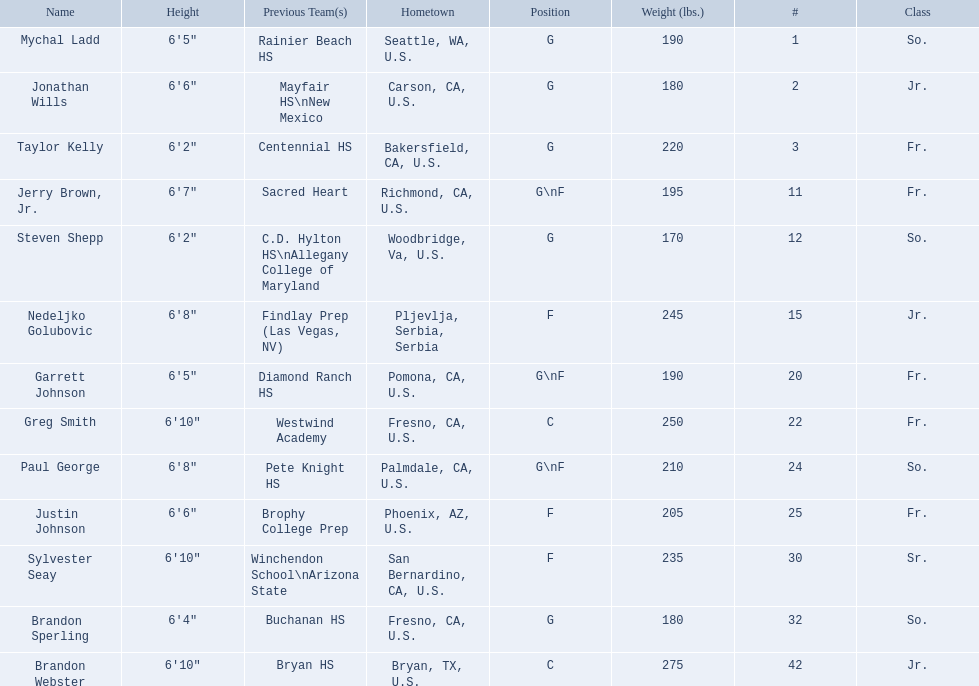Who played during the 2009-10 fresno state bulldogs men's basketball team? Mychal Ladd, Jonathan Wills, Taylor Kelly, Jerry Brown, Jr., Steven Shepp, Nedeljko Golubovic, Garrett Johnson, Greg Smith, Paul George, Justin Johnson, Sylvester Seay, Brandon Sperling, Brandon Webster. What was the position of each player? G, G, G, G\nF, G, F, G\nF, C, G\nF, F, F, G, C. And how tall were they? 6'5", 6'6", 6'2", 6'7", 6'2", 6'8", 6'5", 6'10", 6'8", 6'6", 6'10", 6'4", 6'10". Of these players, who was the shortest forward player? Justin Johnson. 